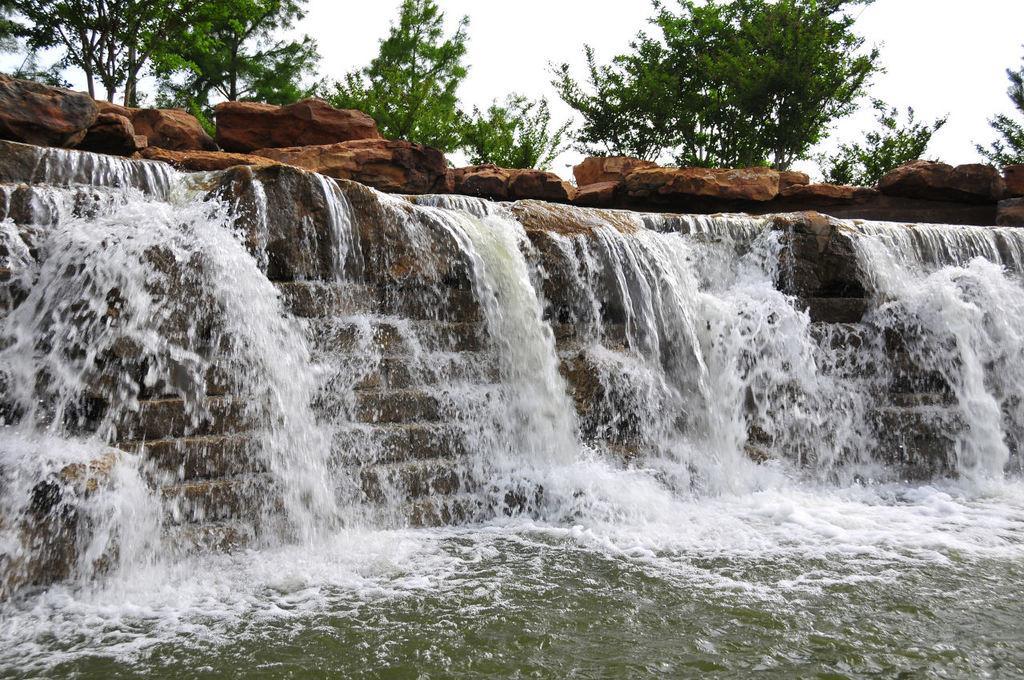Can you describe this image briefly? In this image in the front there is waterfall. In the background there are stones and trees and the sky is cloudy. 